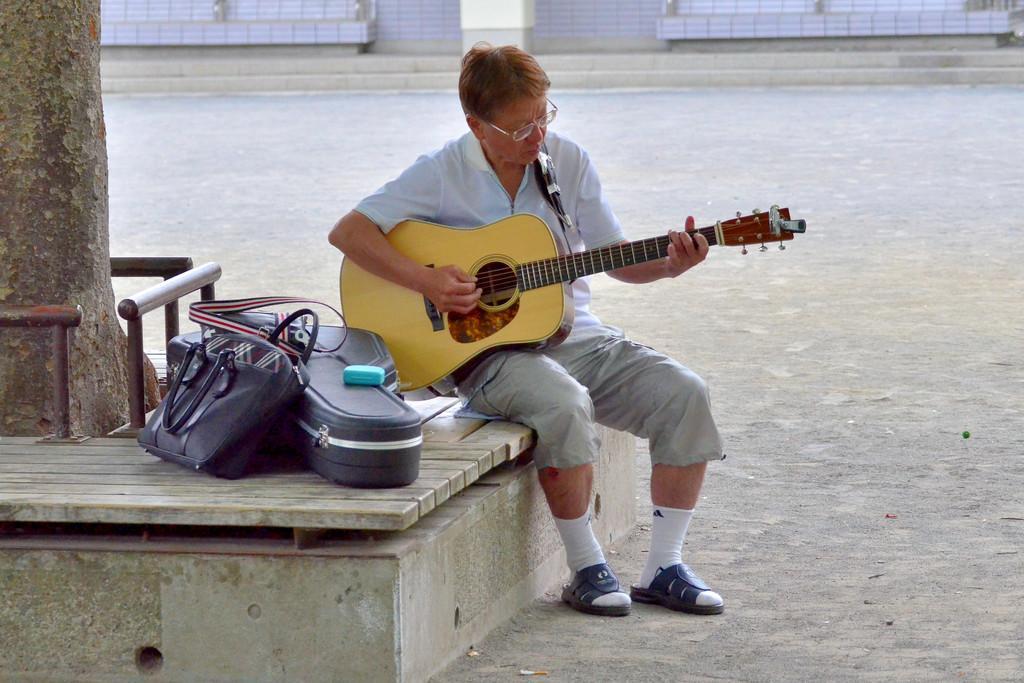Please provide a concise description of this image. In the middle there is a man he wear white shirt ,trouser and sandals. he is playing guitar. On the right there is a guitar box and hand bag. On the right there is a tree. 